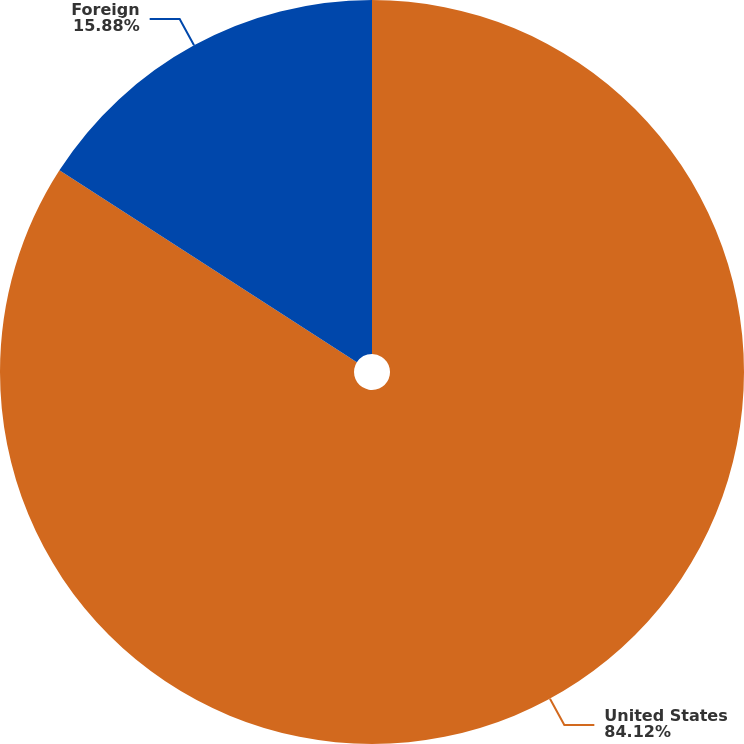<chart> <loc_0><loc_0><loc_500><loc_500><pie_chart><fcel>United States<fcel>Foreign<nl><fcel>84.12%<fcel>15.88%<nl></chart> 